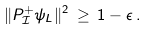<formula> <loc_0><loc_0><loc_500><loc_500>\| P ^ { + } _ { \mathcal { I } } \psi _ { L } \| ^ { 2 } \, \geq \, 1 - \epsilon \, .</formula> 